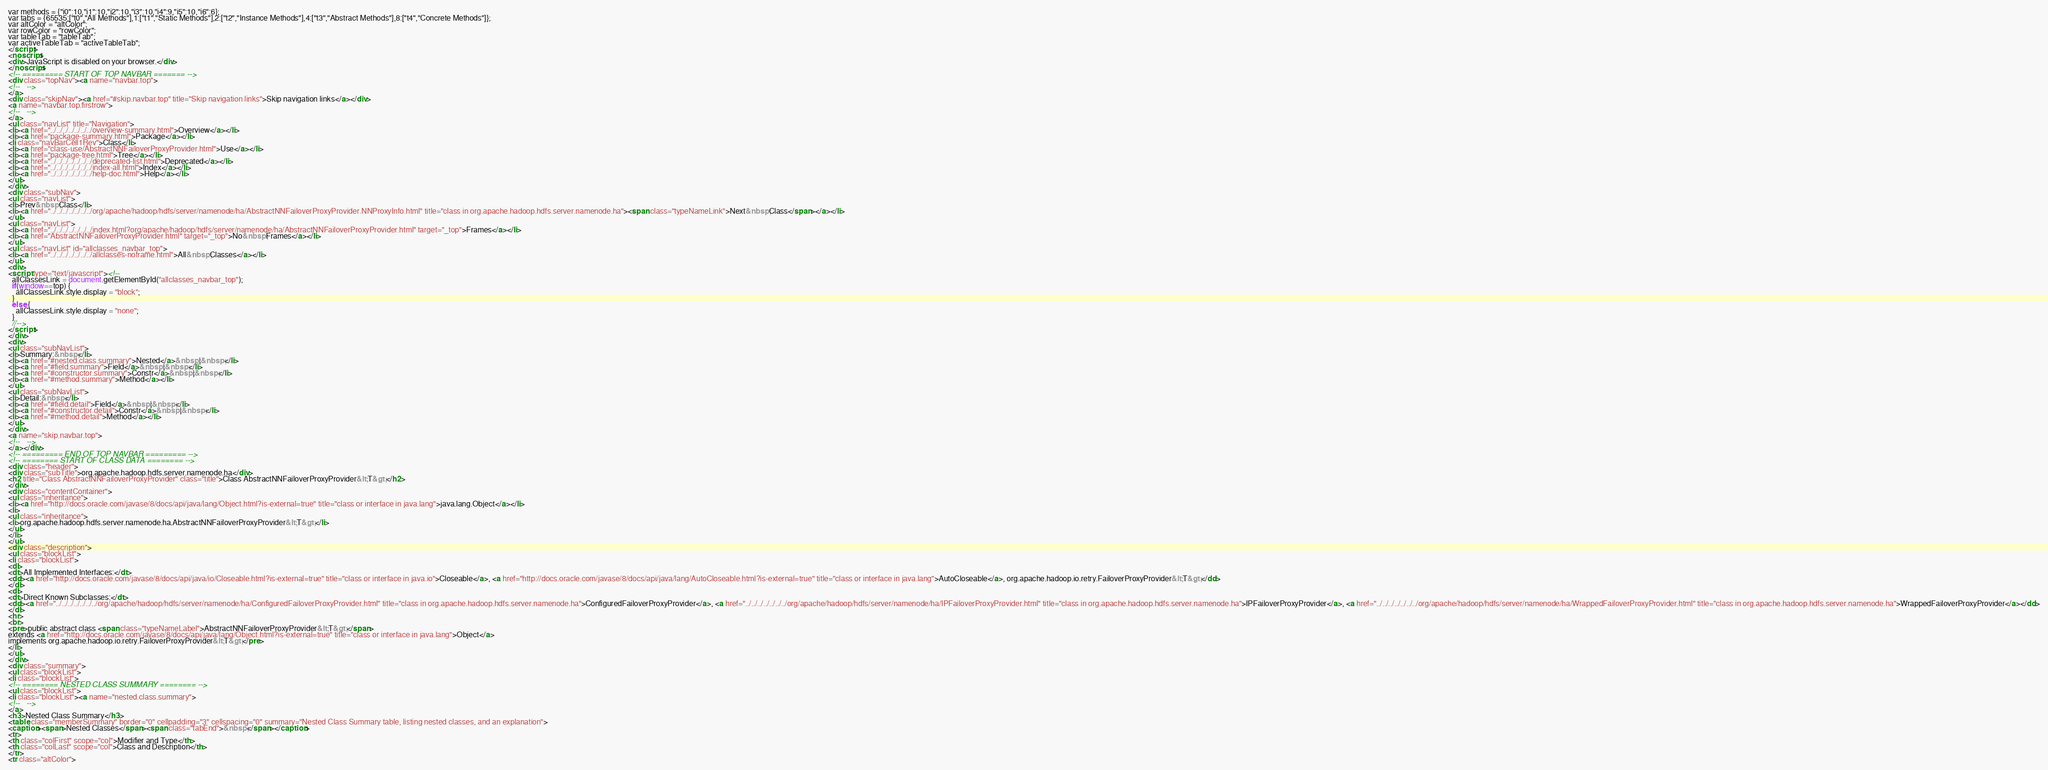<code> <loc_0><loc_0><loc_500><loc_500><_HTML_>var methods = {"i0":10,"i1":10,"i2":10,"i3":10,"i4":9,"i5":10,"i6":6};
var tabs = {65535:["t0","All Methods"],1:["t1","Static Methods"],2:["t2","Instance Methods"],4:["t3","Abstract Methods"],8:["t4","Concrete Methods"]};
var altColor = "altColor";
var rowColor = "rowColor";
var tableTab = "tableTab";
var activeTableTab = "activeTableTab";
</script>
<noscript>
<div>JavaScript is disabled on your browser.</div>
</noscript>
<!-- ========= START OF TOP NAVBAR ======= -->
<div class="topNav"><a name="navbar.top">
<!--   -->
</a>
<div class="skipNav"><a href="#skip.navbar.top" title="Skip navigation links">Skip navigation links</a></div>
<a name="navbar.top.firstrow">
<!--   -->
</a>
<ul class="navList" title="Navigation">
<li><a href="../../../../../../../overview-summary.html">Overview</a></li>
<li><a href="package-summary.html">Package</a></li>
<li class="navBarCell1Rev">Class</li>
<li><a href="class-use/AbstractNNFailoverProxyProvider.html">Use</a></li>
<li><a href="package-tree.html">Tree</a></li>
<li><a href="../../../../../../../deprecated-list.html">Deprecated</a></li>
<li><a href="../../../../../../../index-all.html">Index</a></li>
<li><a href="../../../../../../../help-doc.html">Help</a></li>
</ul>
</div>
<div class="subNav">
<ul class="navList">
<li>Prev&nbsp;Class</li>
<li><a href="../../../../../../../org/apache/hadoop/hdfs/server/namenode/ha/AbstractNNFailoverProxyProvider.NNProxyInfo.html" title="class in org.apache.hadoop.hdfs.server.namenode.ha"><span class="typeNameLink">Next&nbsp;Class</span></a></li>
</ul>
<ul class="navList">
<li><a href="../../../../../../../index.html?org/apache/hadoop/hdfs/server/namenode/ha/AbstractNNFailoverProxyProvider.html" target="_top">Frames</a></li>
<li><a href="AbstractNNFailoverProxyProvider.html" target="_top">No&nbsp;Frames</a></li>
</ul>
<ul class="navList" id="allclasses_navbar_top">
<li><a href="../../../../../../../allclasses-noframe.html">All&nbsp;Classes</a></li>
</ul>
<div>
<script type="text/javascript"><!--
  allClassesLink = document.getElementById("allclasses_navbar_top");
  if(window==top) {
    allClassesLink.style.display = "block";
  }
  else {
    allClassesLink.style.display = "none";
  }
  //-->
</script>
</div>
<div>
<ul class="subNavList">
<li>Summary:&nbsp;</li>
<li><a href="#nested.class.summary">Nested</a>&nbsp;|&nbsp;</li>
<li><a href="#field.summary">Field</a>&nbsp;|&nbsp;</li>
<li><a href="#constructor.summary">Constr</a>&nbsp;|&nbsp;</li>
<li><a href="#method.summary">Method</a></li>
</ul>
<ul class="subNavList">
<li>Detail:&nbsp;</li>
<li><a href="#field.detail">Field</a>&nbsp;|&nbsp;</li>
<li><a href="#constructor.detail">Constr</a>&nbsp;|&nbsp;</li>
<li><a href="#method.detail">Method</a></li>
</ul>
</div>
<a name="skip.navbar.top">
<!--   -->
</a></div>
<!-- ========= END OF TOP NAVBAR ========= -->
<!-- ======== START OF CLASS DATA ======== -->
<div class="header">
<div class="subTitle">org.apache.hadoop.hdfs.server.namenode.ha</div>
<h2 title="Class AbstractNNFailoverProxyProvider" class="title">Class AbstractNNFailoverProxyProvider&lt;T&gt;</h2>
</div>
<div class="contentContainer">
<ul class="inheritance">
<li><a href="http://docs.oracle.com/javase/8/docs/api/java/lang/Object.html?is-external=true" title="class or interface in java.lang">java.lang.Object</a></li>
<li>
<ul class="inheritance">
<li>org.apache.hadoop.hdfs.server.namenode.ha.AbstractNNFailoverProxyProvider&lt;T&gt;</li>
</ul>
</li>
</ul>
<div class="description">
<ul class="blockList">
<li class="blockList">
<dl>
<dt>All Implemented Interfaces:</dt>
<dd><a href="http://docs.oracle.com/javase/8/docs/api/java/io/Closeable.html?is-external=true" title="class or interface in java.io">Closeable</a>, <a href="http://docs.oracle.com/javase/8/docs/api/java/lang/AutoCloseable.html?is-external=true" title="class or interface in java.lang">AutoCloseable</a>, org.apache.hadoop.io.retry.FailoverProxyProvider&lt;T&gt;</dd>
</dl>
<dl>
<dt>Direct Known Subclasses:</dt>
<dd><a href="../../../../../../../org/apache/hadoop/hdfs/server/namenode/ha/ConfiguredFailoverProxyProvider.html" title="class in org.apache.hadoop.hdfs.server.namenode.ha">ConfiguredFailoverProxyProvider</a>, <a href="../../../../../../../org/apache/hadoop/hdfs/server/namenode/ha/IPFailoverProxyProvider.html" title="class in org.apache.hadoop.hdfs.server.namenode.ha">IPFailoverProxyProvider</a>, <a href="../../../../../../../org/apache/hadoop/hdfs/server/namenode/ha/WrappedFailoverProxyProvider.html" title="class in org.apache.hadoop.hdfs.server.namenode.ha">WrappedFailoverProxyProvider</a></dd>
</dl>
<hr>
<br>
<pre>public abstract class <span class="typeNameLabel">AbstractNNFailoverProxyProvider&lt;T&gt;</span>
extends <a href="http://docs.oracle.com/javase/8/docs/api/java/lang/Object.html?is-external=true" title="class or interface in java.lang">Object</a>
implements org.apache.hadoop.io.retry.FailoverProxyProvider&lt;T&gt;</pre>
</li>
</ul>
</div>
<div class="summary">
<ul class="blockList">
<li class="blockList">
<!-- ======== NESTED CLASS SUMMARY ======== -->
<ul class="blockList">
<li class="blockList"><a name="nested.class.summary">
<!--   -->
</a>
<h3>Nested Class Summary</h3>
<table class="memberSummary" border="0" cellpadding="3" cellspacing="0" summary="Nested Class Summary table, listing nested classes, and an explanation">
<caption><span>Nested Classes</span><span class="tabEnd">&nbsp;</span></caption>
<tr>
<th class="colFirst" scope="col">Modifier and Type</th>
<th class="colLast" scope="col">Class and Description</th>
</tr>
<tr class="altColor"></code> 